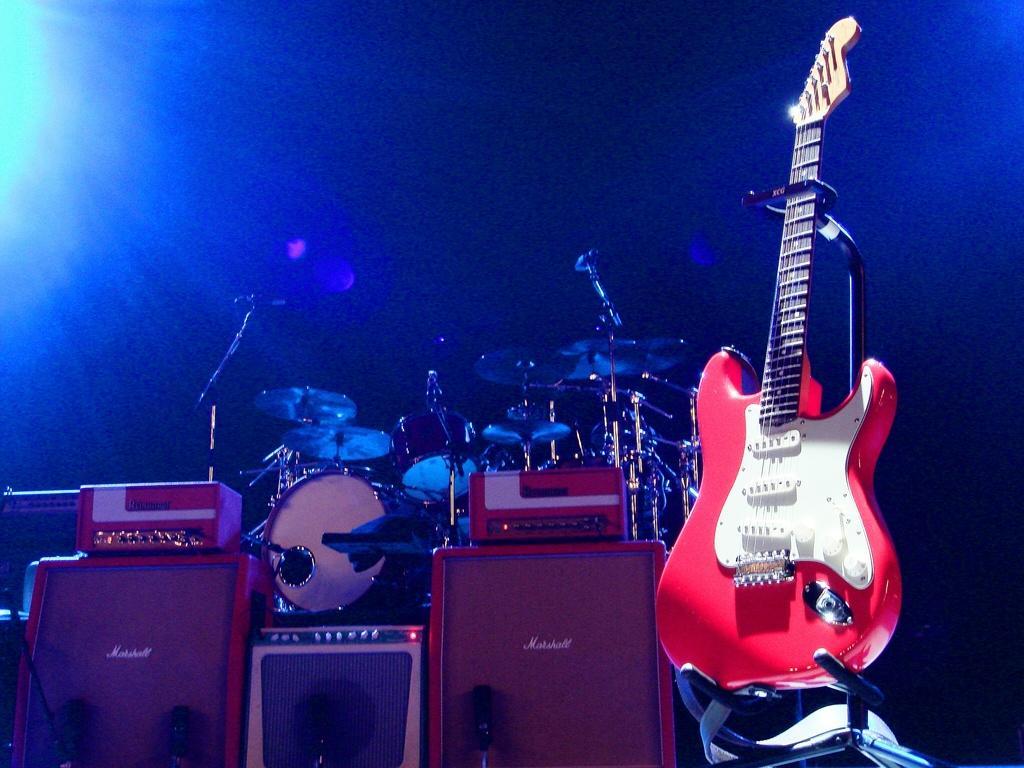Please provide a concise description of this image. In this image I see a guitar, drums and few equipment over here and it is blue in the background. 